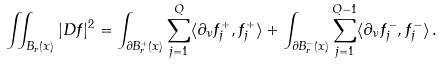<formula> <loc_0><loc_0><loc_500><loc_500>\iint _ { B _ { r } ( x ) } | D f | ^ { 2 } = \int _ { \partial B _ { r } ^ { + } ( x ) } \sum _ { j = 1 } ^ { Q } \langle \partial _ { \nu } f _ { j } ^ { + } , f _ { j } ^ { + } \rangle + \int _ { \partial B _ { r } ^ { - } ( x ) } \sum _ { j = 1 } ^ { Q - 1 } \langle \partial _ { \nu } f _ { j } ^ { - } , f _ { j } ^ { - } \rangle \, .</formula> 